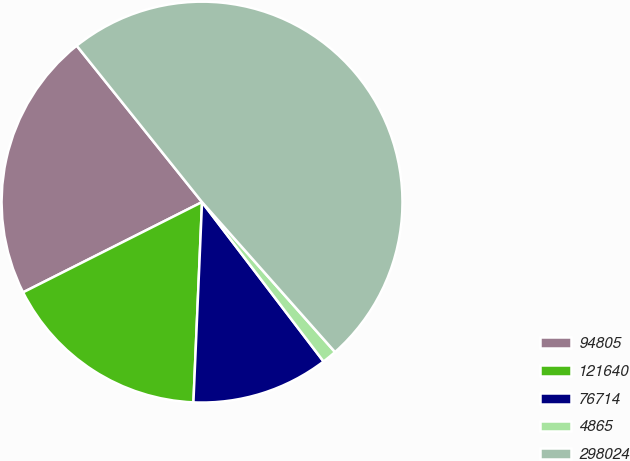<chart> <loc_0><loc_0><loc_500><loc_500><pie_chart><fcel>94805<fcel>121640<fcel>76714<fcel>4865<fcel>298024<nl><fcel>21.68%<fcel>16.88%<fcel>11.05%<fcel>1.18%<fcel>49.2%<nl></chart> 